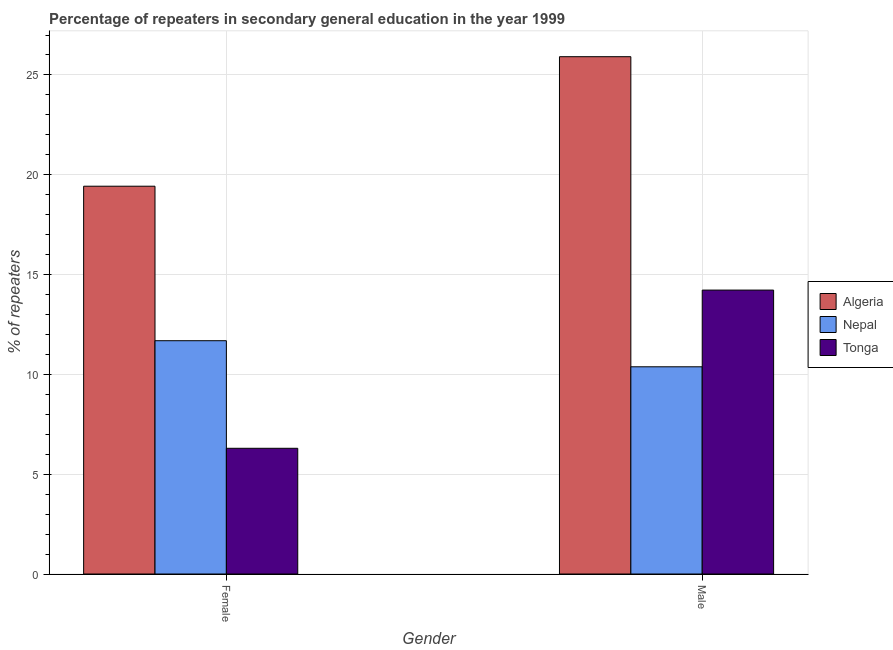How many groups of bars are there?
Provide a short and direct response. 2. Are the number of bars on each tick of the X-axis equal?
Keep it short and to the point. Yes. How many bars are there on the 1st tick from the right?
Give a very brief answer. 3. What is the percentage of male repeaters in Tonga?
Offer a very short reply. 14.22. Across all countries, what is the maximum percentage of male repeaters?
Keep it short and to the point. 25.91. Across all countries, what is the minimum percentage of female repeaters?
Provide a short and direct response. 6.3. In which country was the percentage of female repeaters maximum?
Provide a short and direct response. Algeria. In which country was the percentage of female repeaters minimum?
Provide a succinct answer. Tonga. What is the total percentage of male repeaters in the graph?
Ensure brevity in your answer.  50.52. What is the difference between the percentage of female repeaters in Algeria and that in Tonga?
Offer a terse response. 13.13. What is the difference between the percentage of male repeaters in Nepal and the percentage of female repeaters in Tonga?
Offer a very short reply. 4.08. What is the average percentage of female repeaters per country?
Provide a succinct answer. 12.47. What is the difference between the percentage of male repeaters and percentage of female repeaters in Algeria?
Your answer should be very brief. 6.49. In how many countries, is the percentage of female repeaters greater than 18 %?
Offer a terse response. 1. What is the ratio of the percentage of female repeaters in Algeria to that in Nepal?
Keep it short and to the point. 1.66. In how many countries, is the percentage of female repeaters greater than the average percentage of female repeaters taken over all countries?
Ensure brevity in your answer.  1. What does the 1st bar from the left in Female represents?
Provide a succinct answer. Algeria. What does the 3rd bar from the right in Male represents?
Keep it short and to the point. Algeria. Are all the bars in the graph horizontal?
Make the answer very short. No. Does the graph contain any zero values?
Offer a terse response. No. Does the graph contain grids?
Give a very brief answer. Yes. Where does the legend appear in the graph?
Keep it short and to the point. Center right. What is the title of the graph?
Provide a short and direct response. Percentage of repeaters in secondary general education in the year 1999. Does "Colombia" appear as one of the legend labels in the graph?
Offer a terse response. No. What is the label or title of the X-axis?
Make the answer very short. Gender. What is the label or title of the Y-axis?
Keep it short and to the point. % of repeaters. What is the % of repeaters in Algeria in Female?
Make the answer very short. 19.43. What is the % of repeaters of Nepal in Female?
Offer a very short reply. 11.69. What is the % of repeaters of Tonga in Female?
Keep it short and to the point. 6.3. What is the % of repeaters in Algeria in Male?
Keep it short and to the point. 25.91. What is the % of repeaters of Nepal in Male?
Provide a short and direct response. 10.38. What is the % of repeaters of Tonga in Male?
Offer a terse response. 14.22. Across all Gender, what is the maximum % of repeaters of Algeria?
Make the answer very short. 25.91. Across all Gender, what is the maximum % of repeaters in Nepal?
Your response must be concise. 11.69. Across all Gender, what is the maximum % of repeaters in Tonga?
Provide a short and direct response. 14.22. Across all Gender, what is the minimum % of repeaters of Algeria?
Your answer should be very brief. 19.43. Across all Gender, what is the minimum % of repeaters of Nepal?
Offer a very short reply. 10.38. Across all Gender, what is the minimum % of repeaters in Tonga?
Make the answer very short. 6.3. What is the total % of repeaters of Algeria in the graph?
Offer a very short reply. 45.34. What is the total % of repeaters in Nepal in the graph?
Keep it short and to the point. 22.07. What is the total % of repeaters in Tonga in the graph?
Offer a very short reply. 20.52. What is the difference between the % of repeaters in Algeria in Female and that in Male?
Give a very brief answer. -6.49. What is the difference between the % of repeaters in Nepal in Female and that in Male?
Your response must be concise. 1.31. What is the difference between the % of repeaters in Tonga in Female and that in Male?
Make the answer very short. -7.93. What is the difference between the % of repeaters in Algeria in Female and the % of repeaters in Nepal in Male?
Offer a very short reply. 9.05. What is the difference between the % of repeaters in Algeria in Female and the % of repeaters in Tonga in Male?
Provide a short and direct response. 5.2. What is the difference between the % of repeaters of Nepal in Female and the % of repeaters of Tonga in Male?
Provide a short and direct response. -2.54. What is the average % of repeaters of Algeria per Gender?
Ensure brevity in your answer.  22.67. What is the average % of repeaters in Nepal per Gender?
Your answer should be very brief. 11.03. What is the average % of repeaters in Tonga per Gender?
Keep it short and to the point. 10.26. What is the difference between the % of repeaters in Algeria and % of repeaters in Nepal in Female?
Make the answer very short. 7.74. What is the difference between the % of repeaters of Algeria and % of repeaters of Tonga in Female?
Ensure brevity in your answer.  13.13. What is the difference between the % of repeaters in Nepal and % of repeaters in Tonga in Female?
Offer a terse response. 5.39. What is the difference between the % of repeaters of Algeria and % of repeaters of Nepal in Male?
Offer a very short reply. 15.53. What is the difference between the % of repeaters of Algeria and % of repeaters of Tonga in Male?
Provide a short and direct response. 11.69. What is the difference between the % of repeaters in Nepal and % of repeaters in Tonga in Male?
Your answer should be very brief. -3.84. What is the ratio of the % of repeaters in Algeria in Female to that in Male?
Ensure brevity in your answer.  0.75. What is the ratio of the % of repeaters of Nepal in Female to that in Male?
Offer a terse response. 1.13. What is the ratio of the % of repeaters in Tonga in Female to that in Male?
Your answer should be compact. 0.44. What is the difference between the highest and the second highest % of repeaters of Algeria?
Ensure brevity in your answer.  6.49. What is the difference between the highest and the second highest % of repeaters in Nepal?
Keep it short and to the point. 1.31. What is the difference between the highest and the second highest % of repeaters in Tonga?
Your answer should be very brief. 7.93. What is the difference between the highest and the lowest % of repeaters in Algeria?
Your answer should be very brief. 6.49. What is the difference between the highest and the lowest % of repeaters of Nepal?
Your answer should be compact. 1.31. What is the difference between the highest and the lowest % of repeaters of Tonga?
Keep it short and to the point. 7.93. 